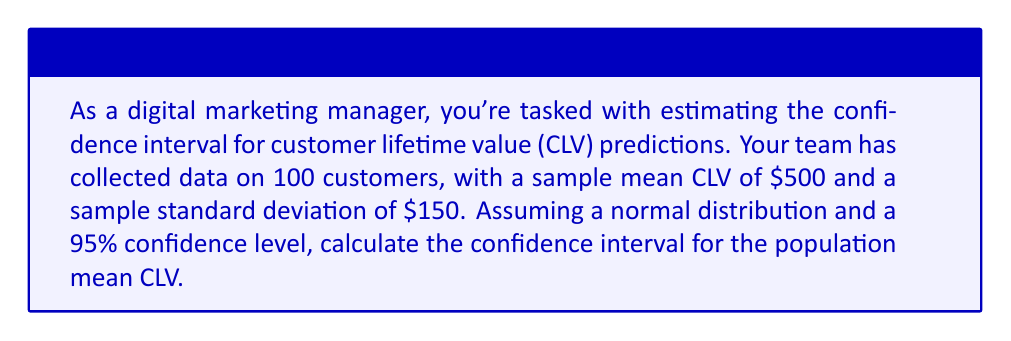Solve this math problem. To calculate the confidence interval for the population mean CLV, we'll follow these steps:

1. Identify the known values:
   - Sample size (n) = 100
   - Sample mean (x̄) = $500
   - Sample standard deviation (s) = $150
   - Confidence level = 95% (α = 0.05)

2. Determine the critical value (z-score) for a 95% confidence level:
   The z-score for a 95% confidence level is 1.96.

3. Calculate the standard error (SE) of the mean:
   $$ SE = \frac{s}{\sqrt{n}} = \frac{150}{\sqrt{100}} = \frac{150}{10} = 15 $$

4. Calculate the margin of error (MOE):
   $$ MOE = z \times SE = 1.96 \times 15 = 29.4 $$

5. Calculate the confidence interval:
   Lower bound: $$ x̄ - MOE = 500 - 29.4 = 470.6 $$
   Upper bound: $$ x̄ + MOE = 500 + 29.4 = 529.4 $$

Therefore, the 95% confidence interval for the population mean CLV is ($470.6, $529.4).
Answer: ($470.6, $529.4) 